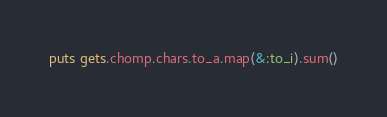Convert code to text. <code><loc_0><loc_0><loc_500><loc_500><_Ruby_>puts gets.chomp.chars.to_a.map(&:to_i).sum()</code> 